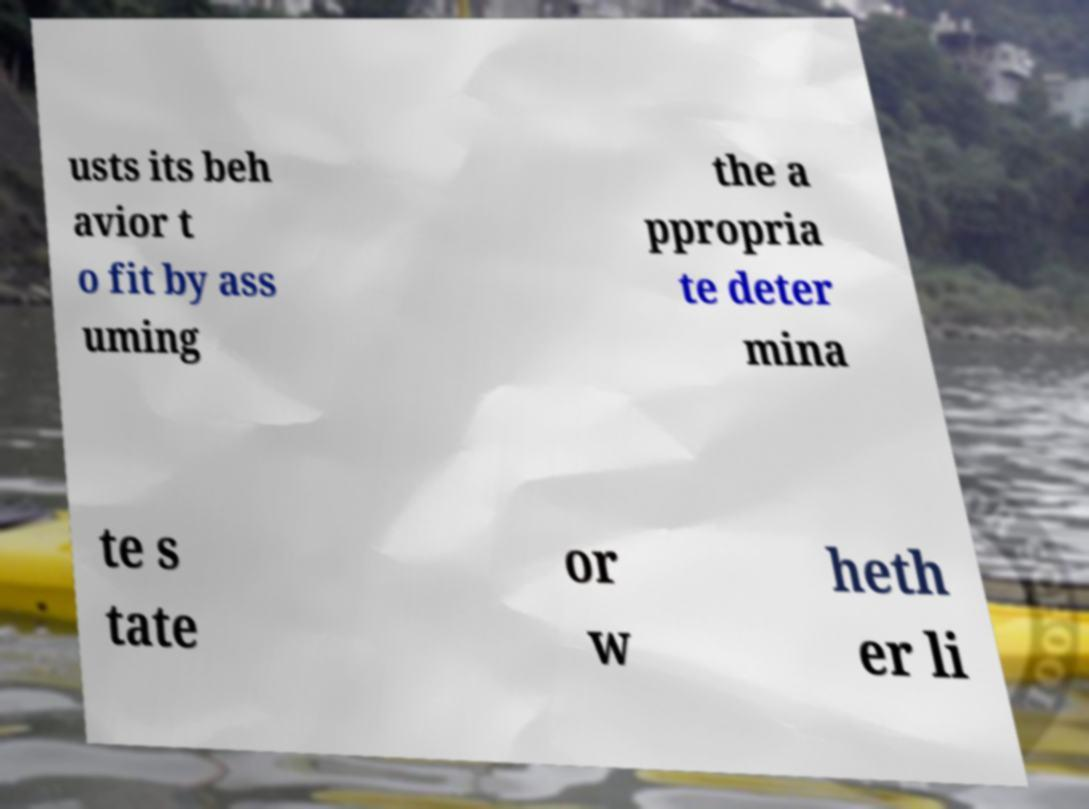Please read and relay the text visible in this image. What does it say? usts its beh avior t o fit by ass uming the a ppropria te deter mina te s tate or w heth er li 